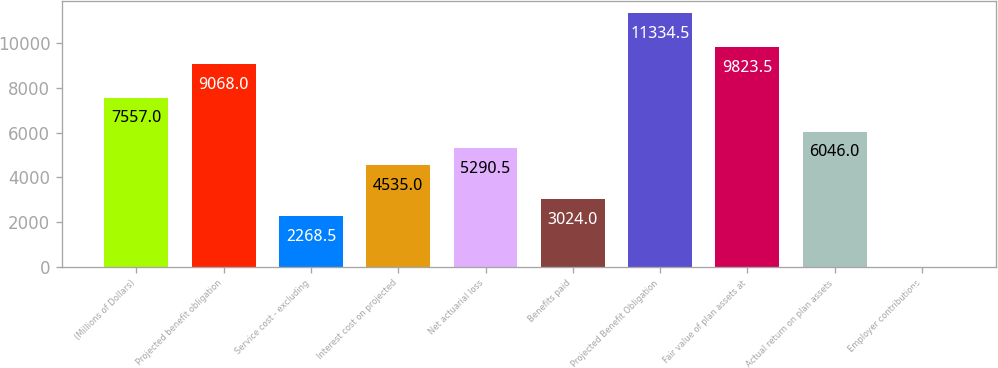Convert chart to OTSL. <chart><loc_0><loc_0><loc_500><loc_500><bar_chart><fcel>(Millions of Dollars)<fcel>Projected benefit obligation<fcel>Service cost - excluding<fcel>Interest cost on projected<fcel>Net actuarial loss<fcel>Benefits paid<fcel>Projected Benefit Obligation<fcel>Fair value of plan assets at<fcel>Actual return on plan assets<fcel>Employer contributions<nl><fcel>7557<fcel>9068<fcel>2268.5<fcel>4535<fcel>5290.5<fcel>3024<fcel>11334.5<fcel>9823.5<fcel>6046<fcel>2<nl></chart> 